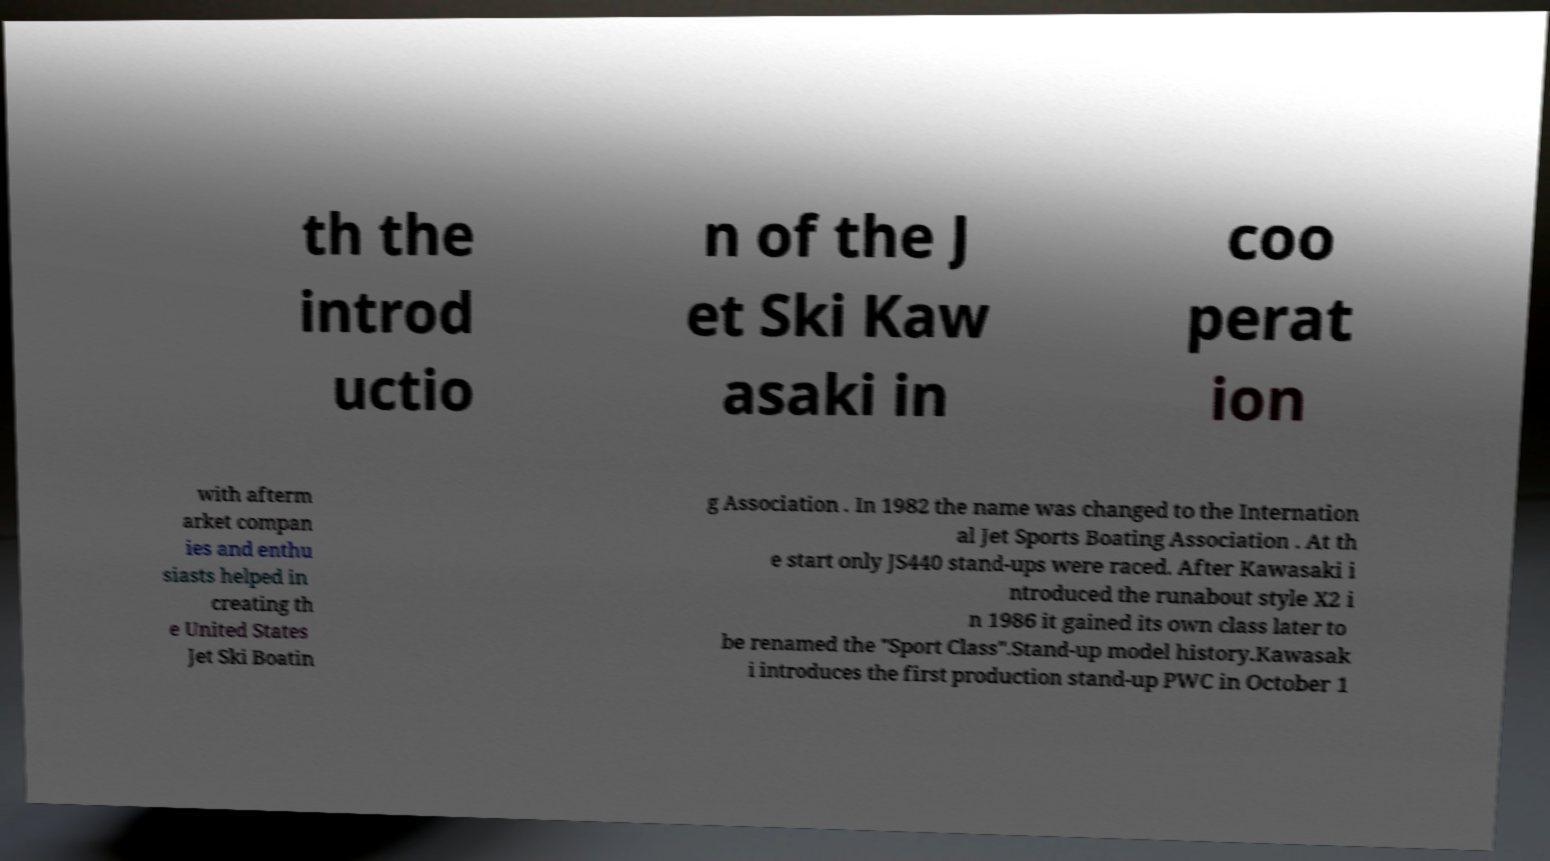Please identify and transcribe the text found in this image. th the introd uctio n of the J et Ski Kaw asaki in coo perat ion with afterm arket compan ies and enthu siasts helped in creating th e United States Jet Ski Boatin g Association . In 1982 the name was changed to the Internation al Jet Sports Boating Association . At th e start only JS440 stand-ups were raced. After Kawasaki i ntroduced the runabout style X2 i n 1986 it gained its own class later to be renamed the "Sport Class".Stand-up model history.Kawasak i introduces the first production stand-up PWC in October 1 